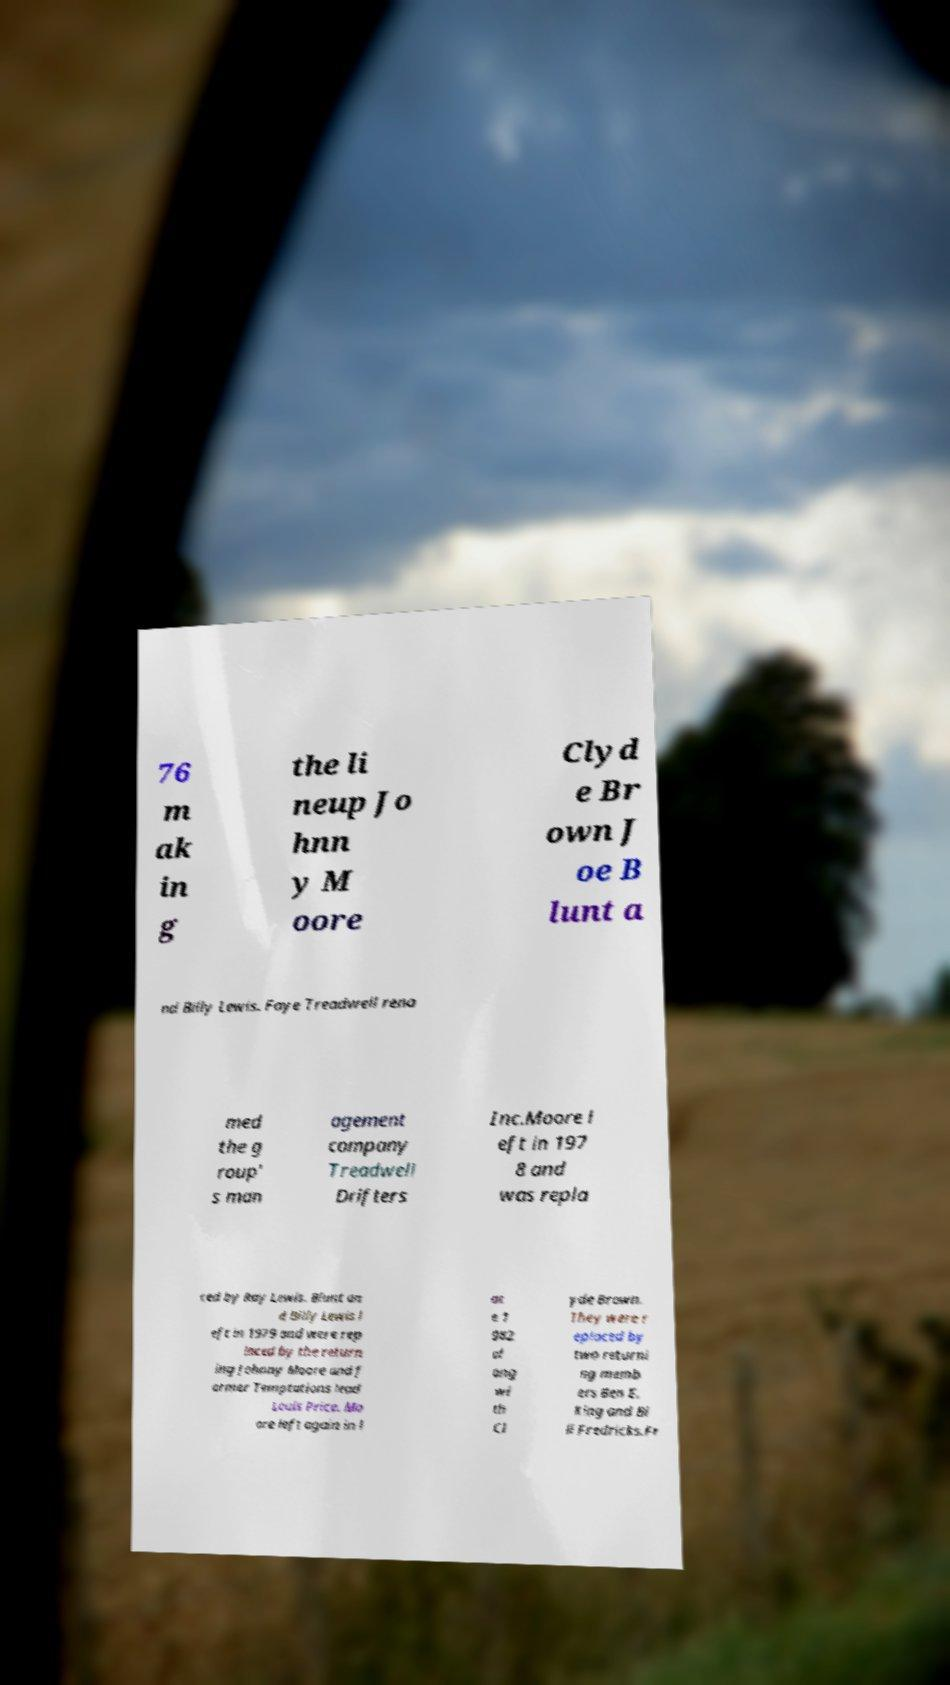Could you extract and type out the text from this image? 76 m ak in g the li neup Jo hnn y M oore Clyd e Br own J oe B lunt a nd Billy Lewis. Faye Treadwell rena med the g roup' s man agement company Treadwell Drifters Inc.Moore l eft in 197 8 and was repla ced by Ray Lewis. Blunt an d Billy Lewis l eft in 1979 and were rep laced by the return ing Johnny Moore and f ormer Temptations lead Louis Price. Mo ore left again in l at e 1 982 al ong wi th Cl yde Brown. They were r eplaced by two returni ng memb ers Ben E. King and Bi ll Fredricks.Fr 